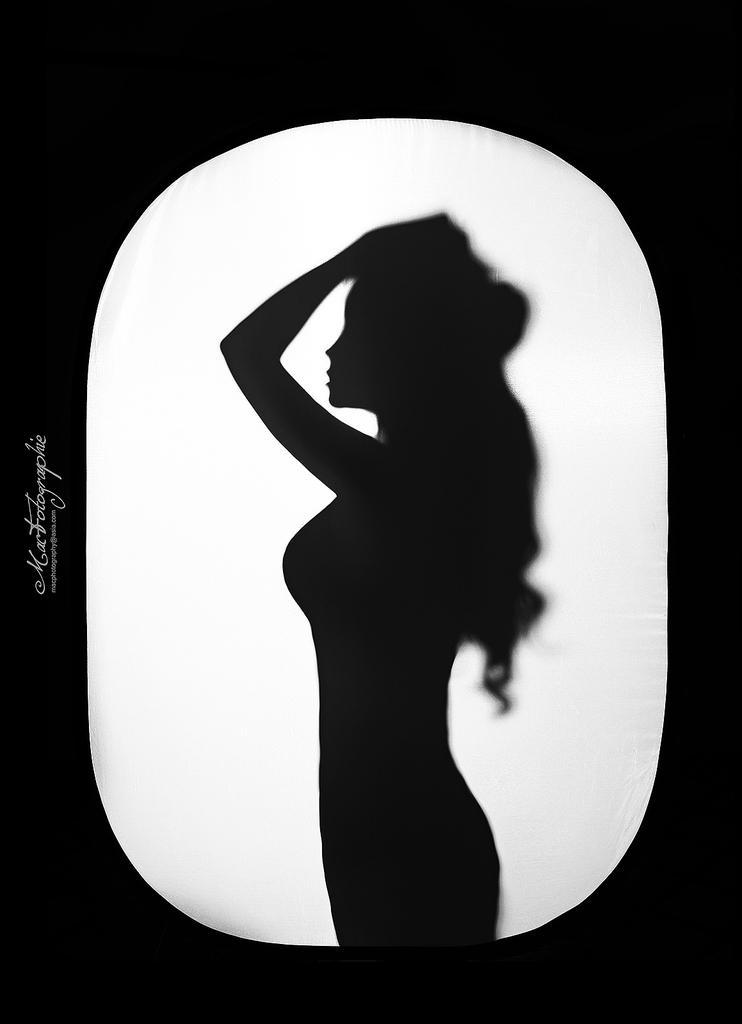Describe this image in one or two sentences. In this image we can see the silhouette, on the left we can see the written text. 